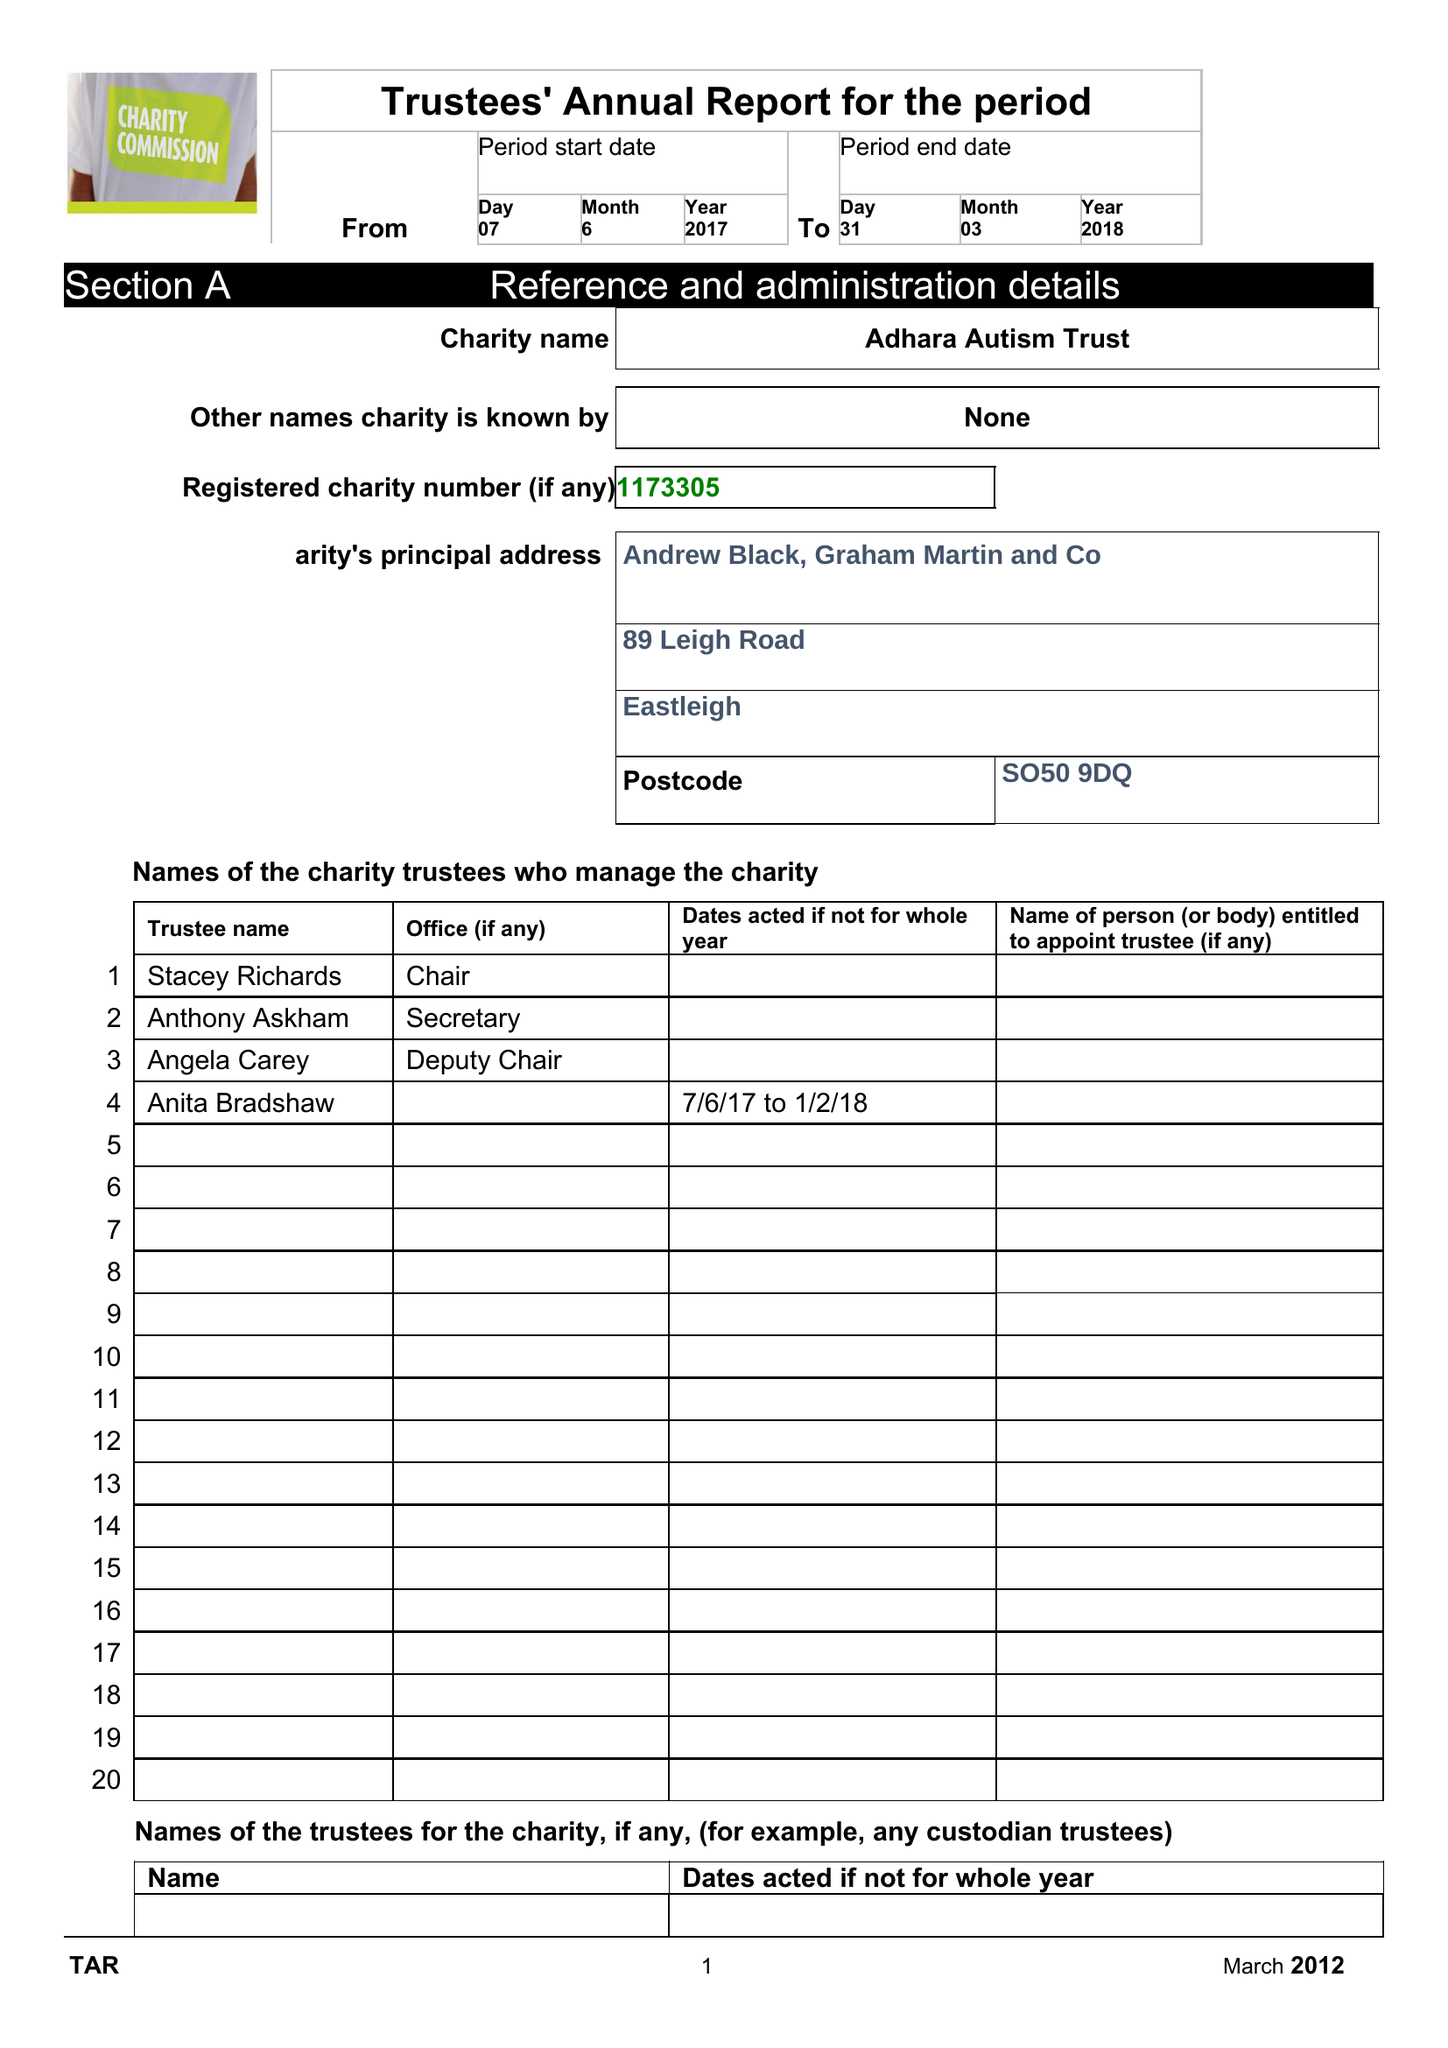What is the value for the report_date?
Answer the question using a single word or phrase. 2018-03-31 